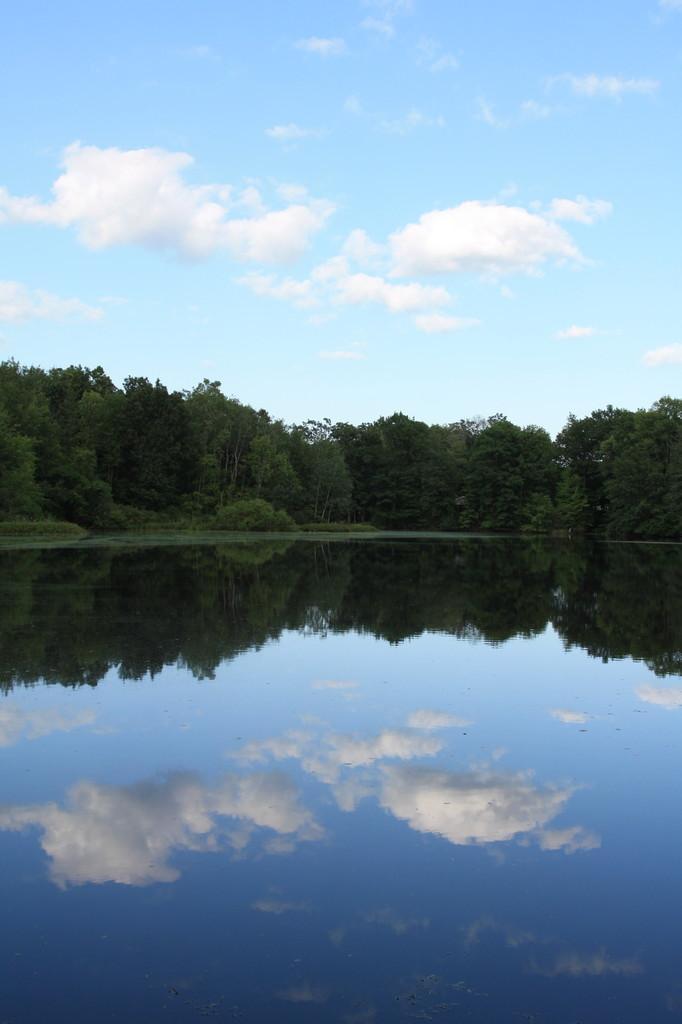How would you summarize this image in a sentence or two? In the image in the center we can see water,grass,trees,sky and clouds. 